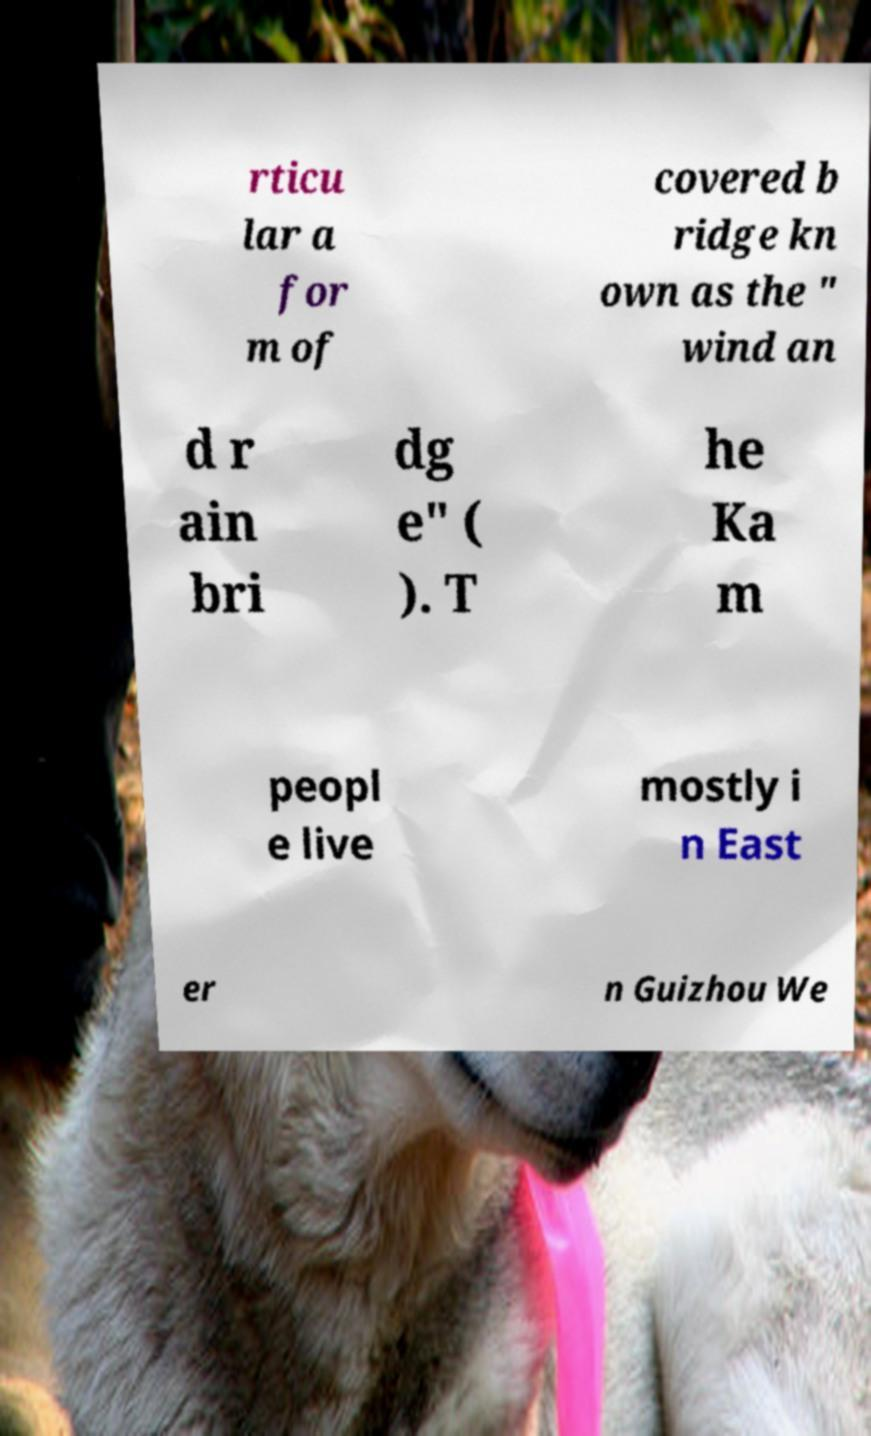For documentation purposes, I need the text within this image transcribed. Could you provide that? rticu lar a for m of covered b ridge kn own as the " wind an d r ain bri dg e" ( ). T he Ka m peopl e live mostly i n East er n Guizhou We 